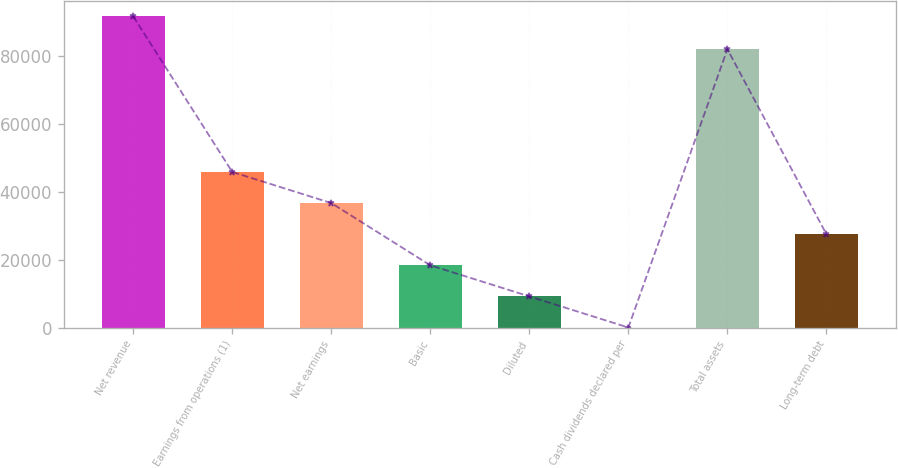Convert chart. <chart><loc_0><loc_0><loc_500><loc_500><bar_chart><fcel>Net revenue<fcel>Earnings from operations (1)<fcel>Net earnings<fcel>Basic<fcel>Diluted<fcel>Cash dividends declared per<fcel>Total assets<fcel>Long-term debt<nl><fcel>91658<fcel>45829.2<fcel>36663.4<fcel>18331.9<fcel>9166.09<fcel>0.32<fcel>81981<fcel>27497.6<nl></chart> 